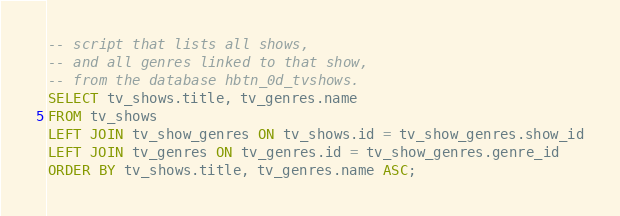Convert code to text. <code><loc_0><loc_0><loc_500><loc_500><_SQL_>-- script that lists all shows,
-- and all genres linked to that show,
-- from the database hbtn_0d_tvshows.
SELECT tv_shows.title, tv_genres.name
FROM tv_shows
LEFT JOIN tv_show_genres ON tv_shows.id = tv_show_genres.show_id
LEFT JOIN tv_genres ON tv_genres.id = tv_show_genres.genre_id
ORDER BY tv_shows.title, tv_genres.name ASC;
</code> 